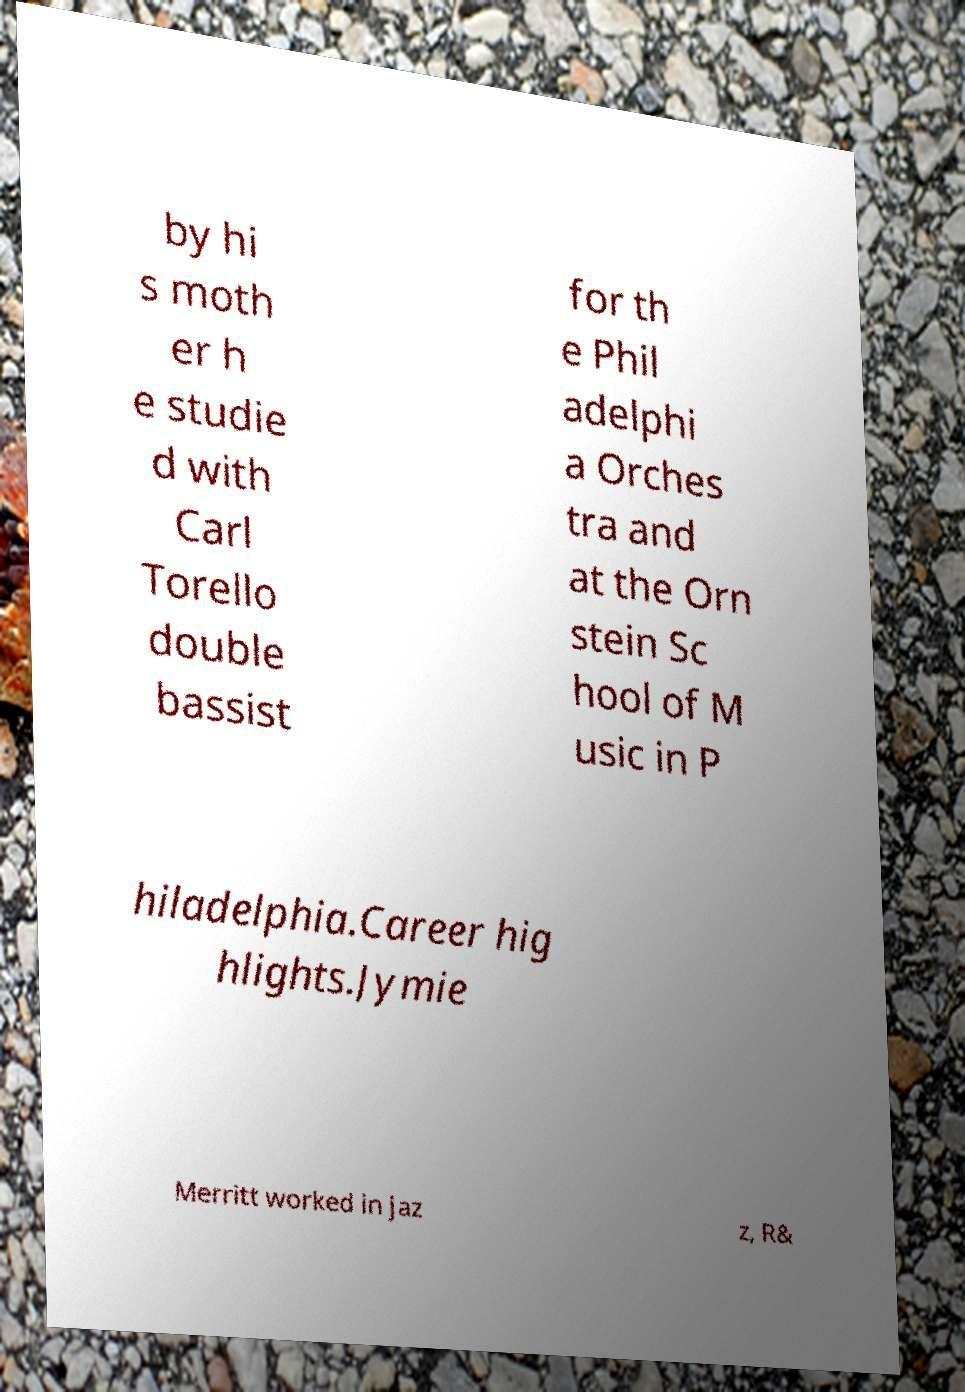Can you read and provide the text displayed in the image?This photo seems to have some interesting text. Can you extract and type it out for me? by hi s moth er h e studie d with Carl Torello double bassist for th e Phil adelphi a Orches tra and at the Orn stein Sc hool of M usic in P hiladelphia.Career hig hlights.Jymie Merritt worked in jaz z, R& 